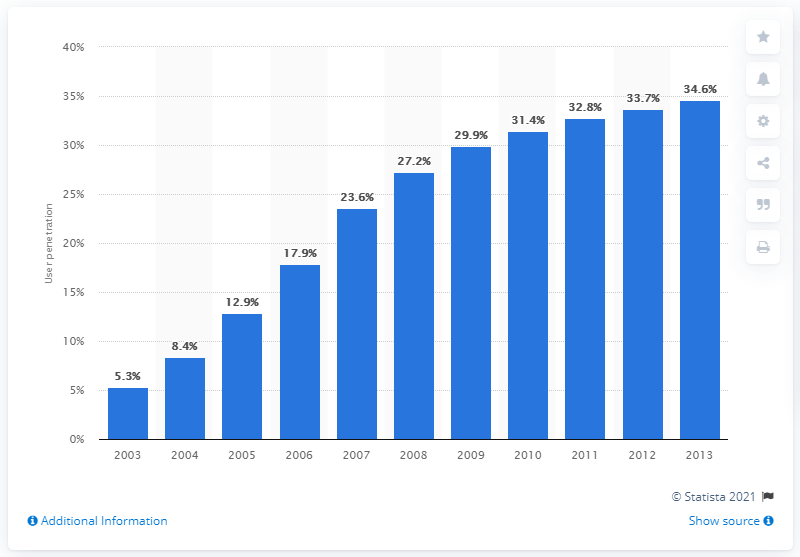Mention a couple of crucial points in this snapshot. In 2013, 34.6% of internet users in Germany had fixed broadband connections. 